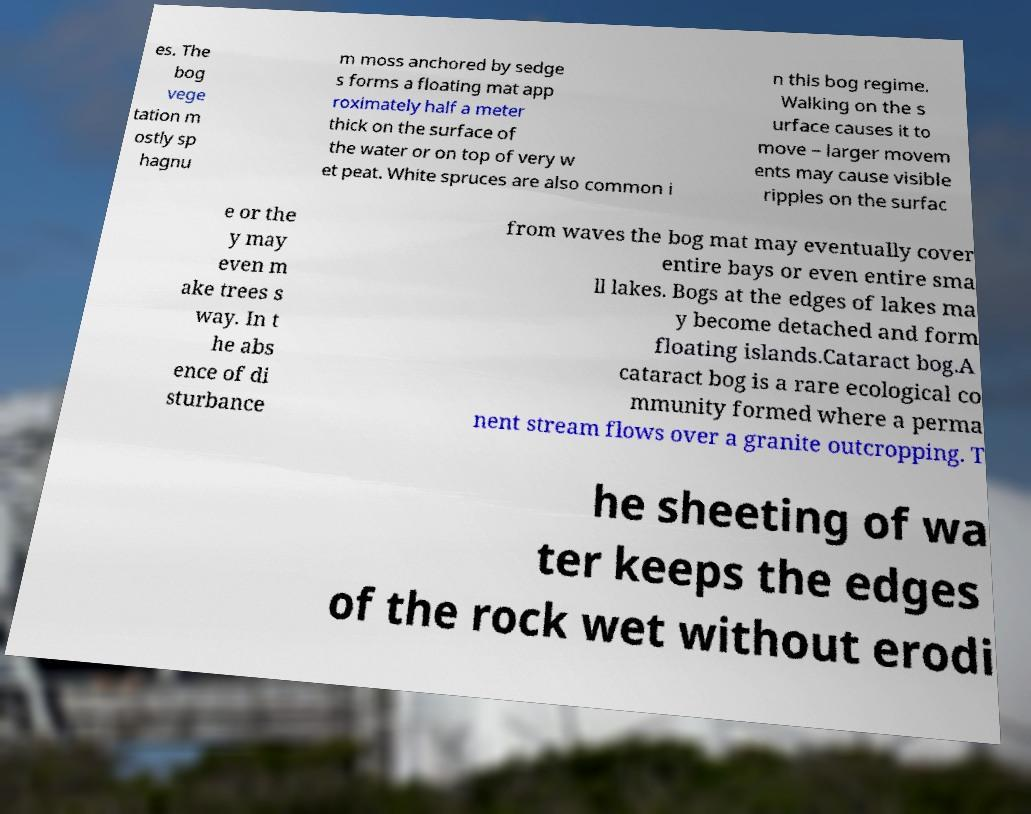For documentation purposes, I need the text within this image transcribed. Could you provide that? es. The bog vege tation m ostly sp hagnu m moss anchored by sedge s forms a floating mat app roximately half a meter thick on the surface of the water or on top of very w et peat. White spruces are also common i n this bog regime. Walking on the s urface causes it to move – larger movem ents may cause visible ripples on the surfac e or the y may even m ake trees s way. In t he abs ence of di sturbance from waves the bog mat may eventually cover entire bays or even entire sma ll lakes. Bogs at the edges of lakes ma y become detached and form floating islands.Cataract bog.A cataract bog is a rare ecological co mmunity formed where a perma nent stream flows over a granite outcropping. T he sheeting of wa ter keeps the edges of the rock wet without erodi 